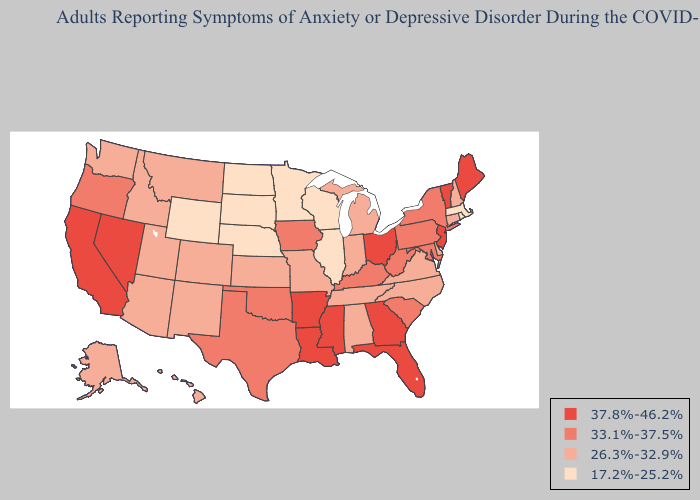What is the highest value in states that border Arizona?
Short answer required. 37.8%-46.2%. Does New York have the highest value in the Northeast?
Be succinct. No. Does the map have missing data?
Give a very brief answer. No. What is the lowest value in states that border Louisiana?
Concise answer only. 33.1%-37.5%. What is the value of Texas?
Keep it brief. 33.1%-37.5%. Does Arizona have the lowest value in the USA?
Answer briefly. No. Name the states that have a value in the range 37.8%-46.2%?
Be succinct. Arkansas, California, Florida, Georgia, Louisiana, Maine, Mississippi, Nevada, New Jersey, Ohio, Vermont. Name the states that have a value in the range 17.2%-25.2%?
Answer briefly. Illinois, Massachusetts, Minnesota, Nebraska, North Dakota, Rhode Island, South Dakota, Wisconsin, Wyoming. What is the value of South Carolina?
Keep it brief. 33.1%-37.5%. What is the value of New Jersey?
Write a very short answer. 37.8%-46.2%. Among the states that border North Carolina , does Georgia have the highest value?
Short answer required. Yes. What is the value of Wisconsin?
Write a very short answer. 17.2%-25.2%. What is the lowest value in the USA?
Concise answer only. 17.2%-25.2%. Name the states that have a value in the range 37.8%-46.2%?
Short answer required. Arkansas, California, Florida, Georgia, Louisiana, Maine, Mississippi, Nevada, New Jersey, Ohio, Vermont. Name the states that have a value in the range 37.8%-46.2%?
Give a very brief answer. Arkansas, California, Florida, Georgia, Louisiana, Maine, Mississippi, Nevada, New Jersey, Ohio, Vermont. 